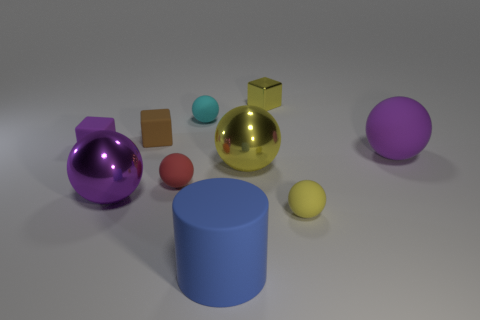Subtract all purple rubber blocks. How many blocks are left? 2 Subtract all purple cylinders. How many yellow balls are left? 2 Subtract all cyan spheres. How many spheres are left? 5 Subtract 1 blocks. How many blocks are left? 2 Subtract all purple rubber blocks. Subtract all purple balls. How many objects are left? 7 Add 9 yellow matte balls. How many yellow matte balls are left? 10 Add 5 matte spheres. How many matte spheres exist? 9 Subtract 0 cyan cylinders. How many objects are left? 10 Subtract all blocks. How many objects are left? 7 Subtract all green blocks. Subtract all brown cylinders. How many blocks are left? 3 